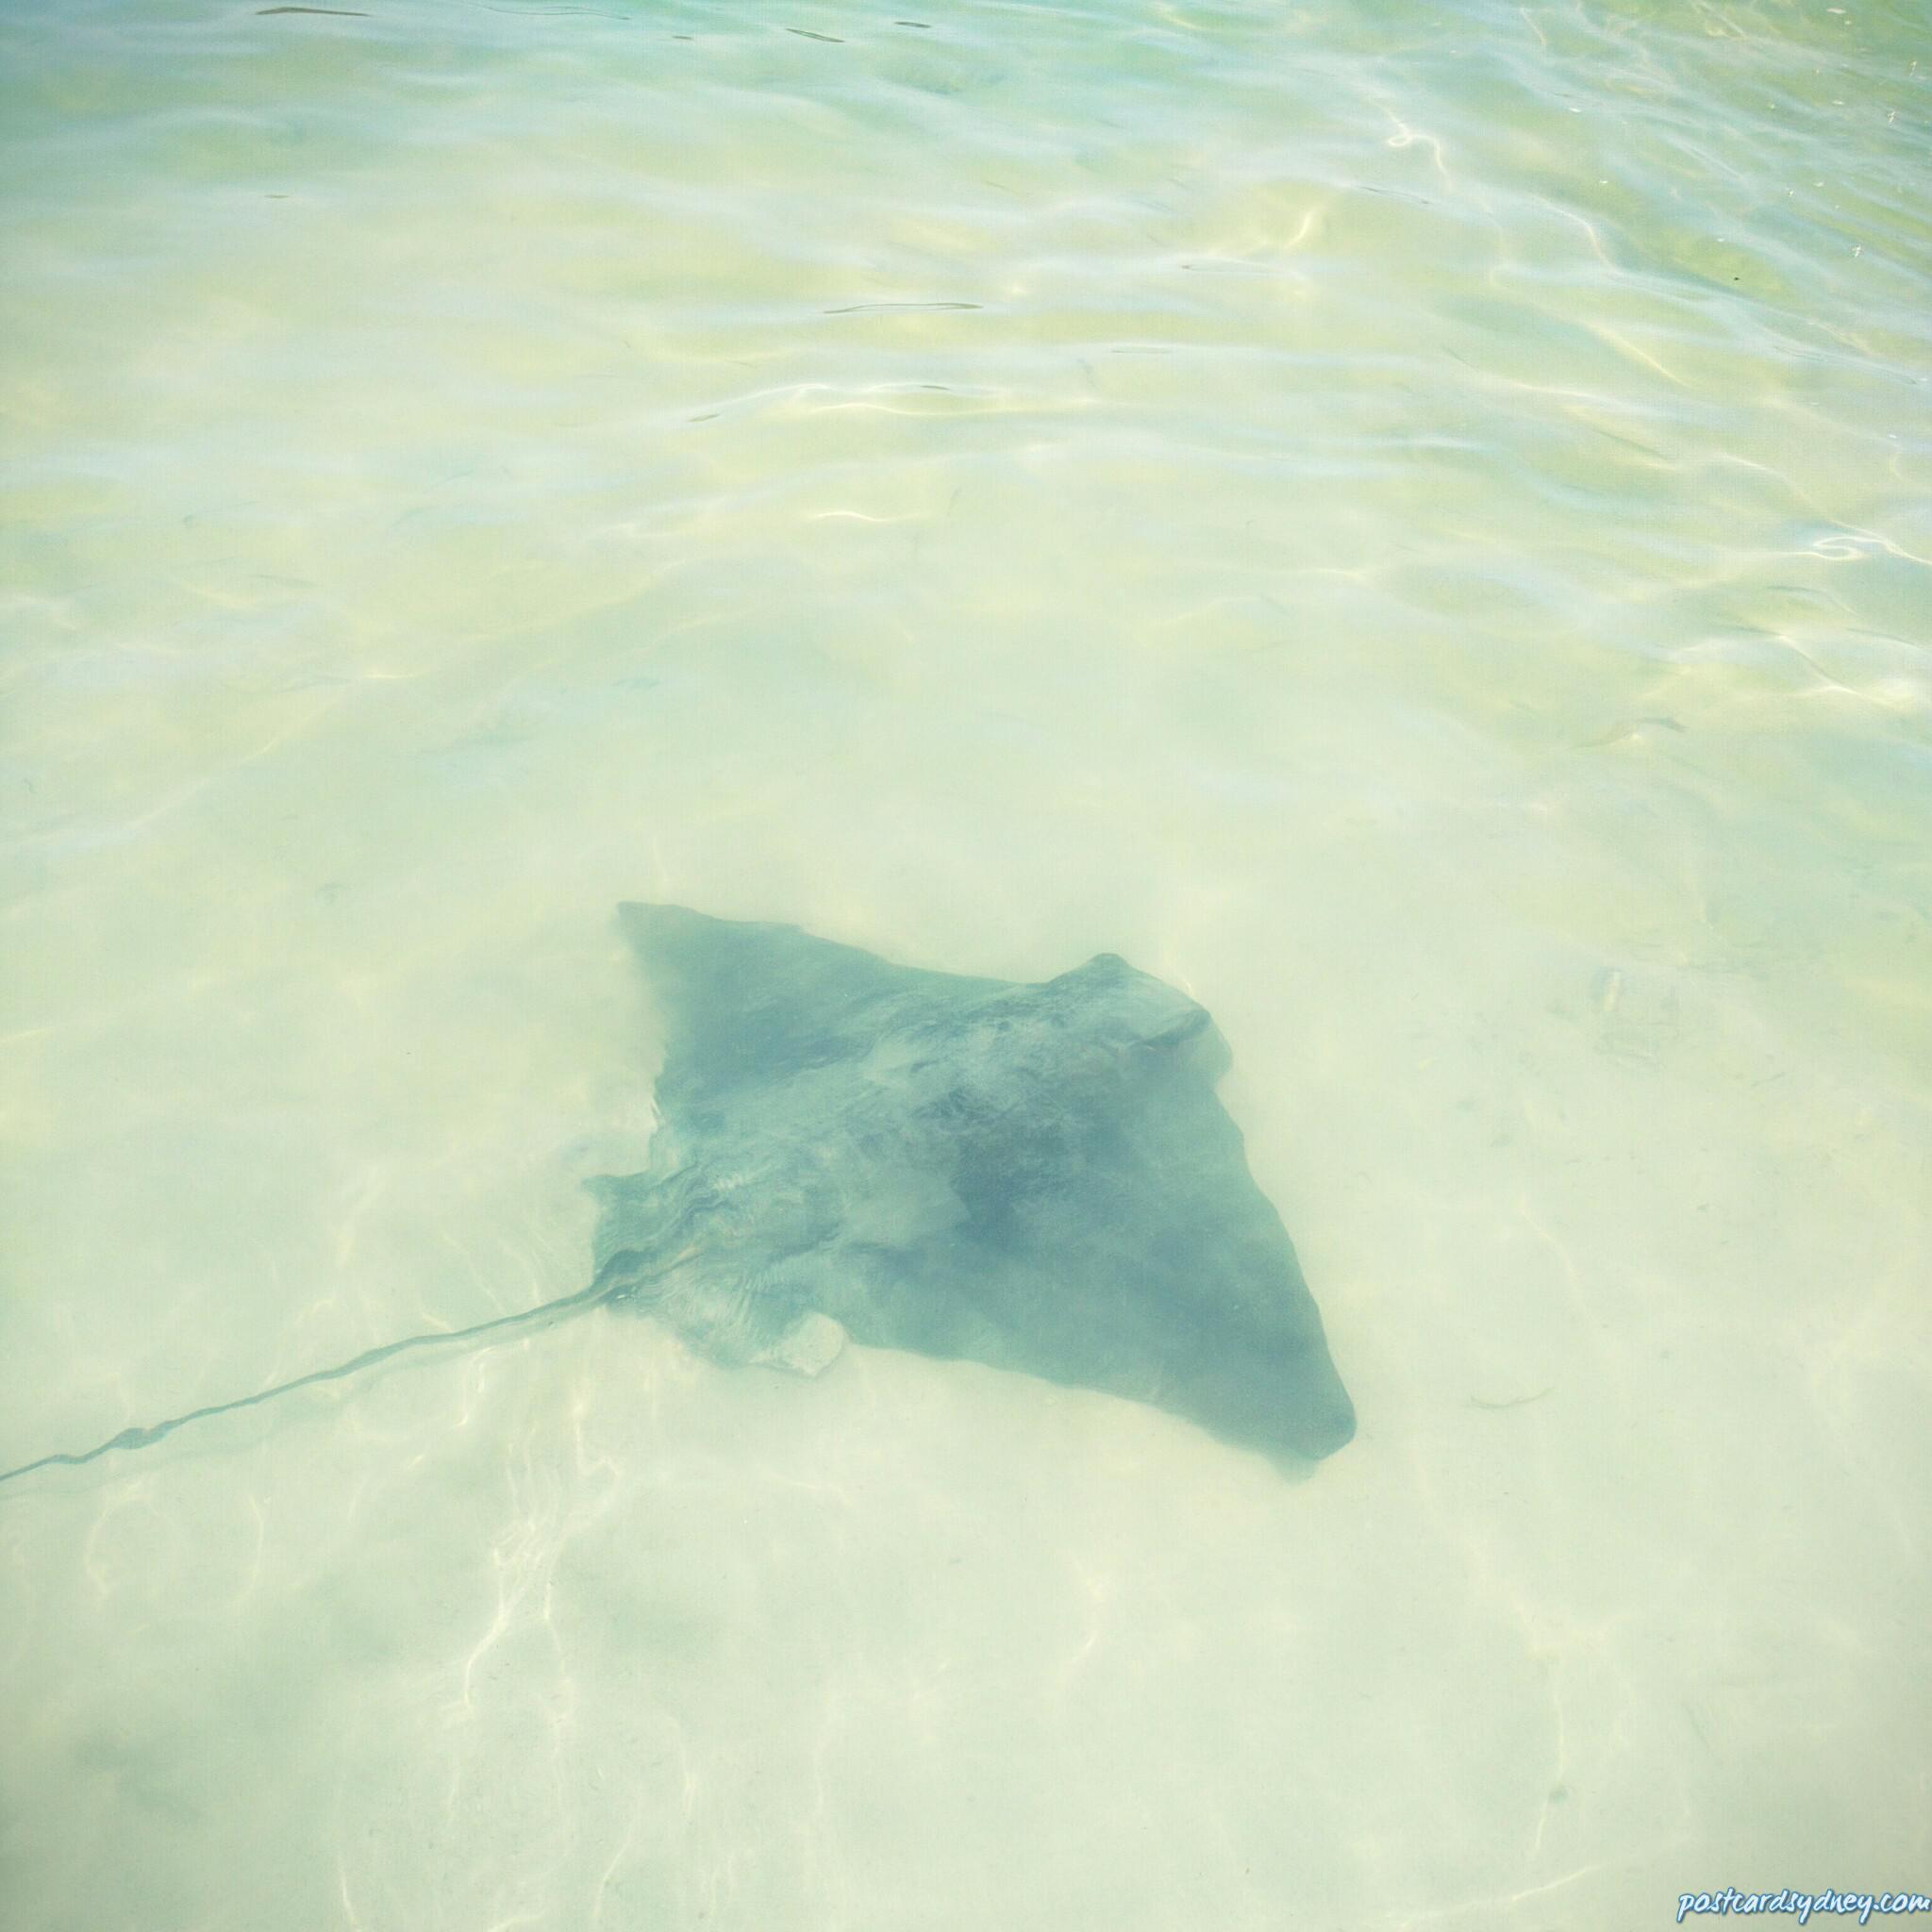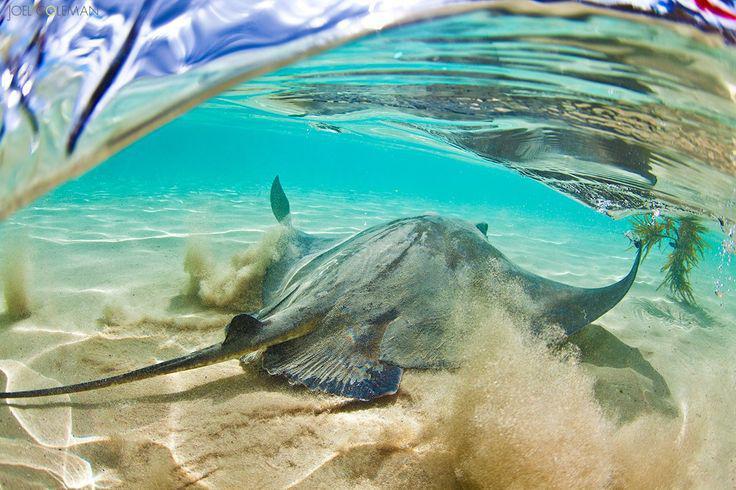The first image is the image on the left, the second image is the image on the right. Considering the images on both sides, is "In the right image a human is petting a stingray" valid? Answer yes or no. No. The first image is the image on the left, the second image is the image on the right. Assess this claim about the two images: "There is a person reaching down and touching a stingray.". Correct or not? Answer yes or no. No. 